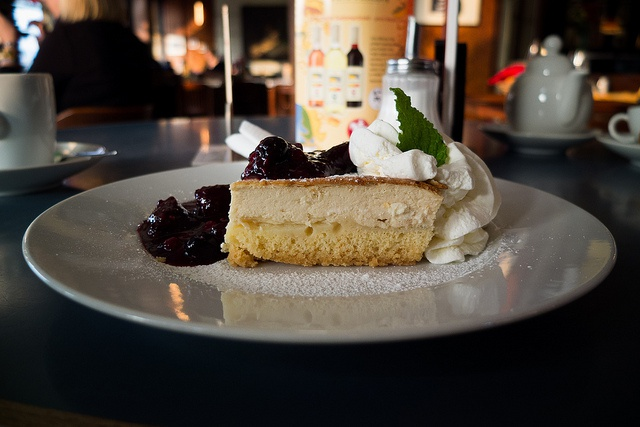Describe the objects in this image and their specific colors. I can see dining table in black, gray, tan, and darkgray tones, cake in black, tan, and lightgray tones, bottle in black, beige, tan, and red tones, cup in black, gray, and darkgray tones, and cup in black and gray tones in this image. 